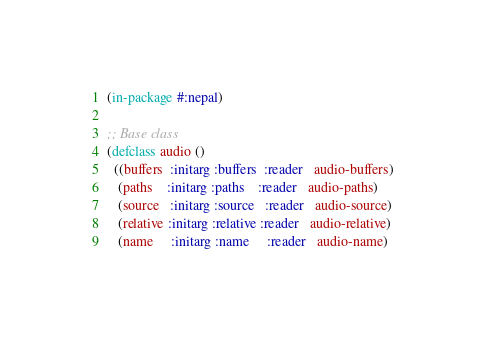<code> <loc_0><loc_0><loc_500><loc_500><_Lisp_>(in-package #:nepal)

;; Base class
(defclass audio ()
  ((buffers  :initarg :buffers  :reader   audio-buffers)
   (paths    :initarg :paths    :reader   audio-paths)
   (source   :initarg :source   :reader   audio-source)
   (relative :initarg :relative :reader   audio-relative)
   (name     :initarg :name     :reader   audio-name)</code> 